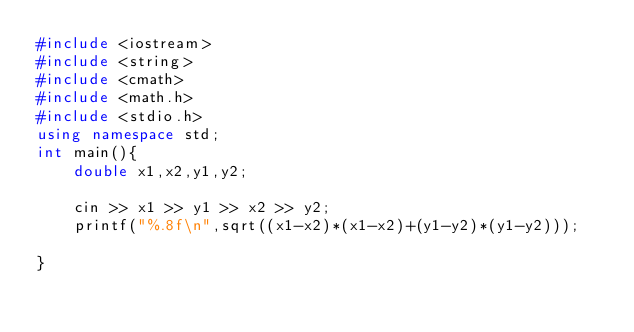<code> <loc_0><loc_0><loc_500><loc_500><_C++_>#include <iostream>
#include <string>
#include <cmath>
#include <math.h>
#include <stdio.h>
using namespace std;
int main(){
    double x1,x2,y1,y2;
    
    cin >> x1 >> y1 >> x2 >> y2;
    printf("%.8f\n",sqrt((x1-x2)*(x1-x2)+(y1-y2)*(y1-y2)));
    
}
</code> 